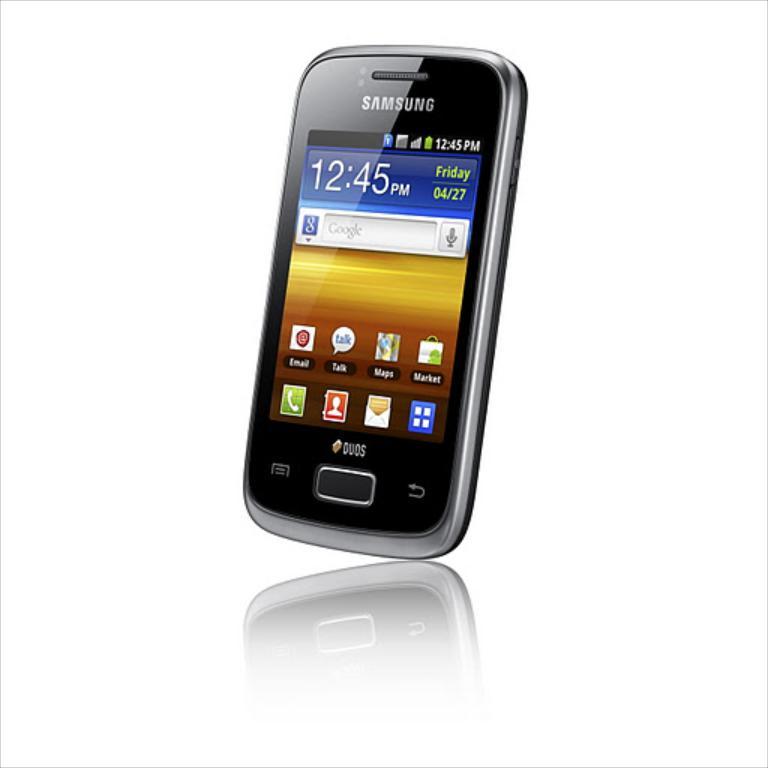What website is shown?
Make the answer very short. Google. What time is shown on the phone?
Provide a short and direct response. 12:45. 